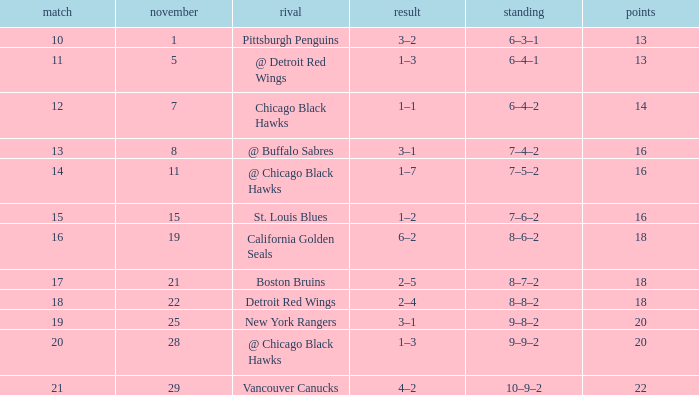What is the highest November that has a game less than 12, and @ detroit red wings as the opponent? 5.0. 